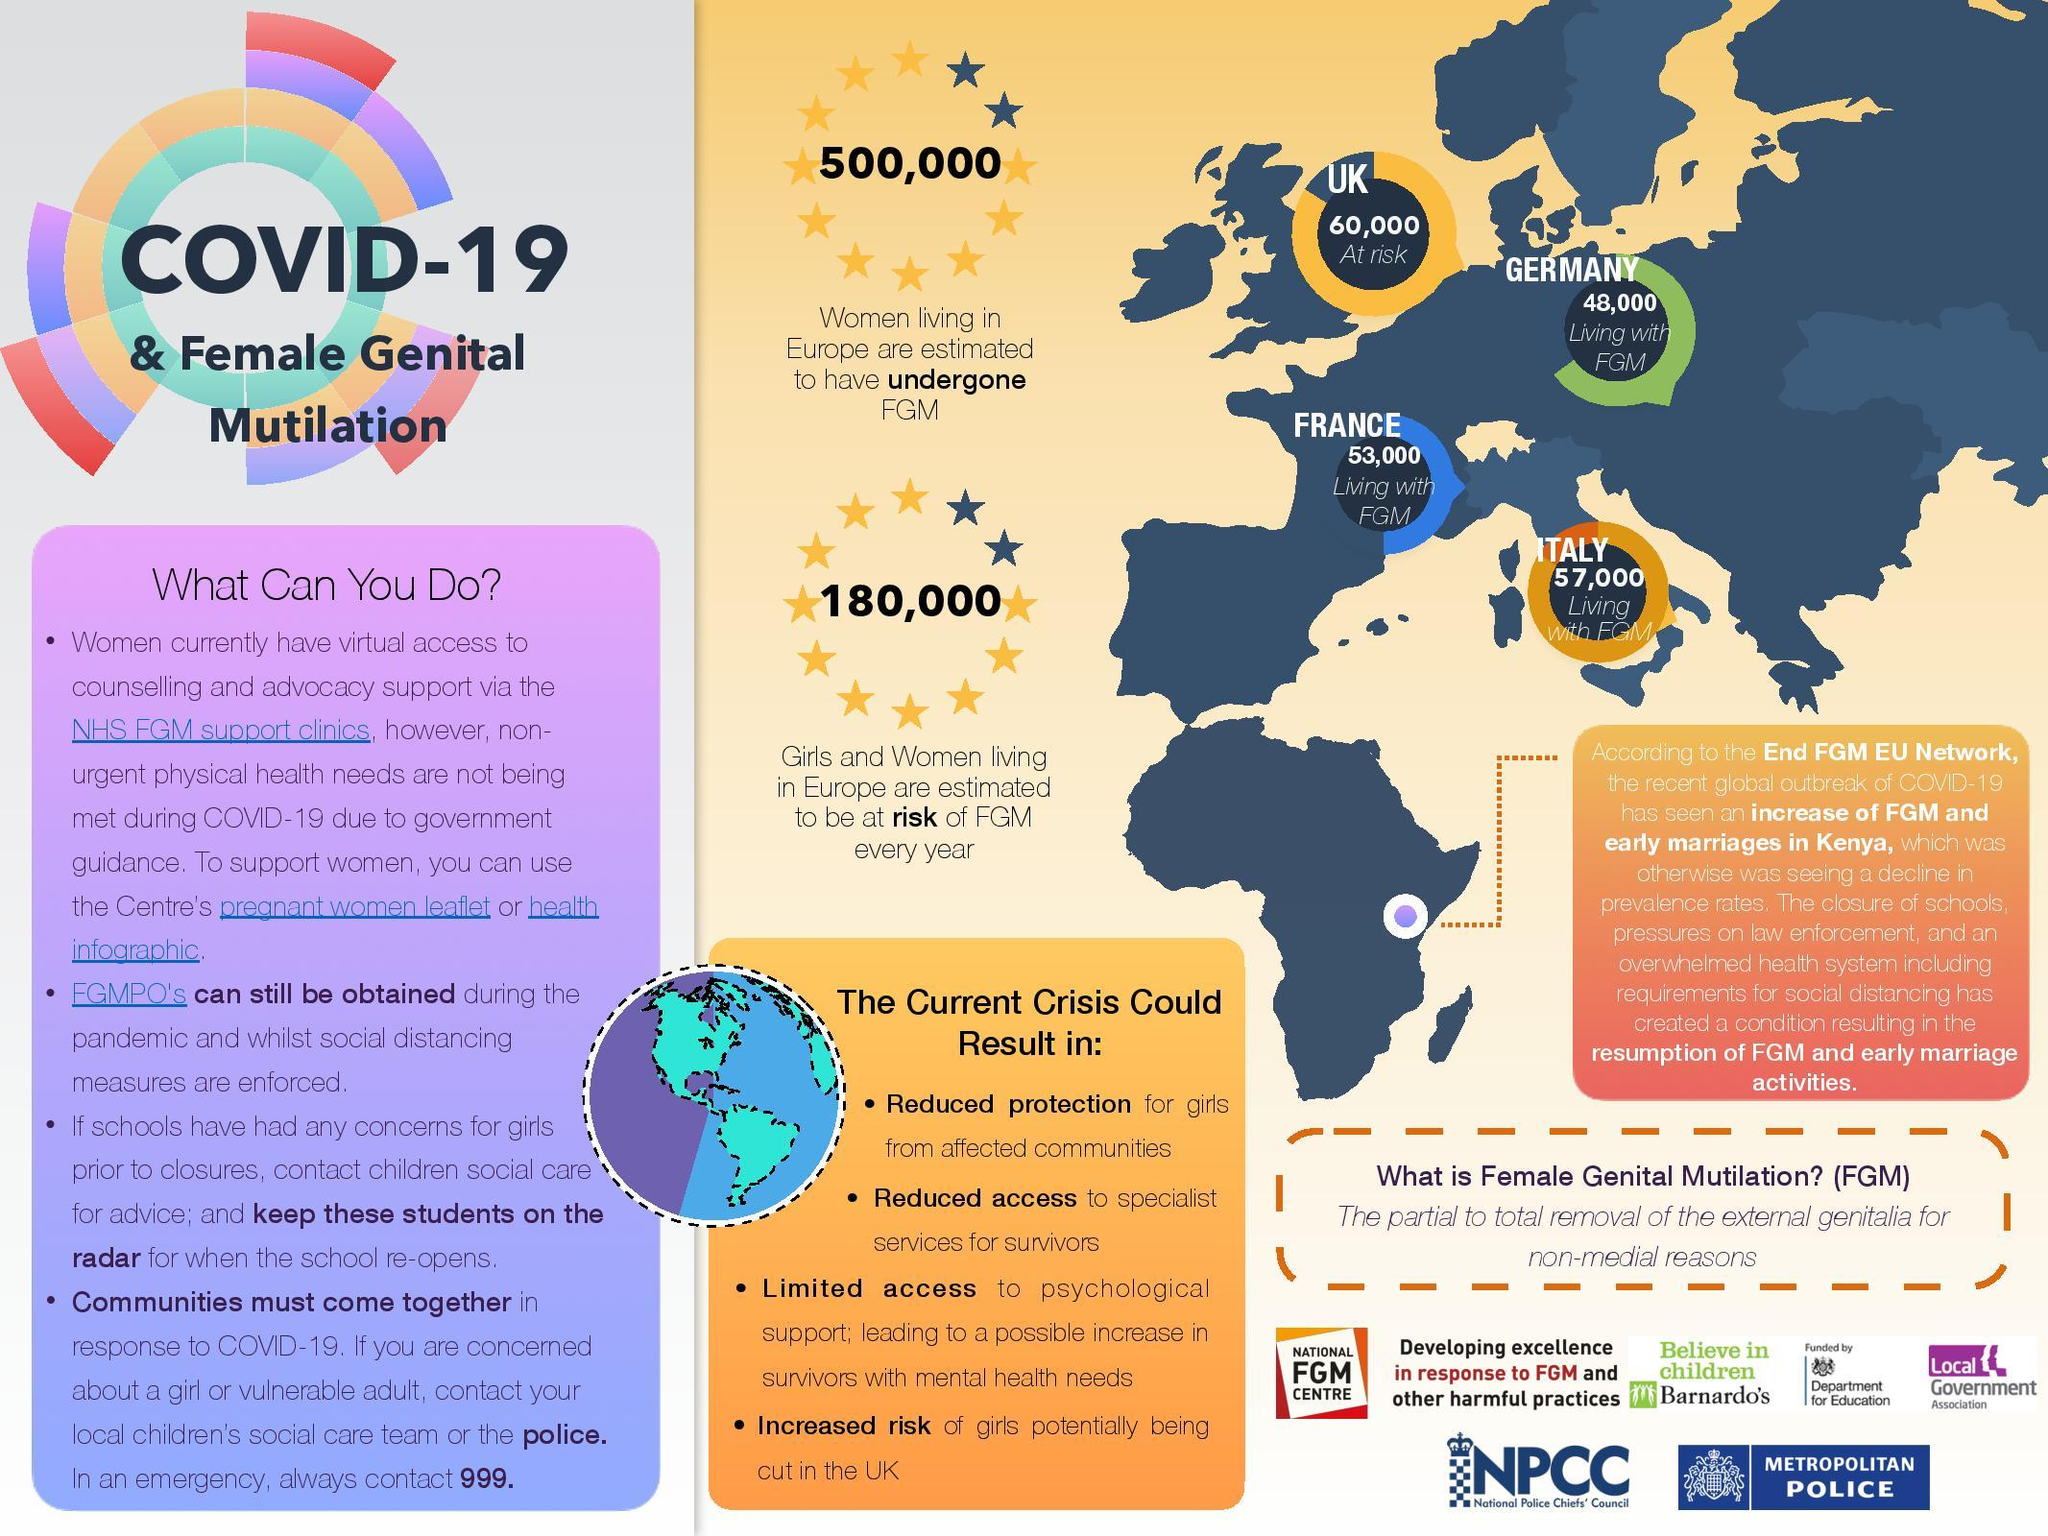Mention a couple of crucial points in this snapshot. The infographic contains the names of four countries. It is estimated that approximately 500,000 women living in Europe have undergone female genital mutilation (FGM). 